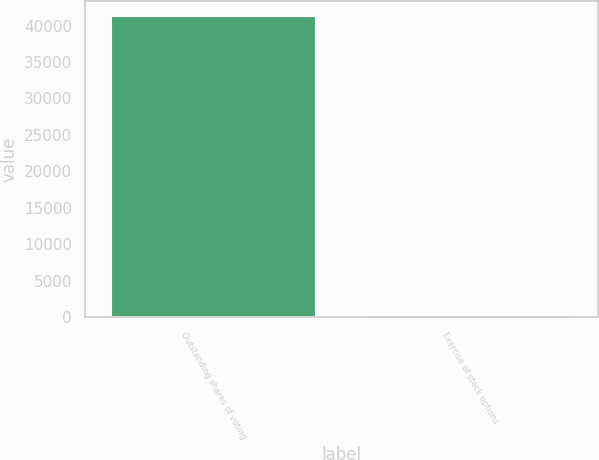<chart> <loc_0><loc_0><loc_500><loc_500><bar_chart><fcel>Outstanding shares of voting<fcel>Exercise of stock options<nl><fcel>41279.9<fcel>262<nl></chart> 